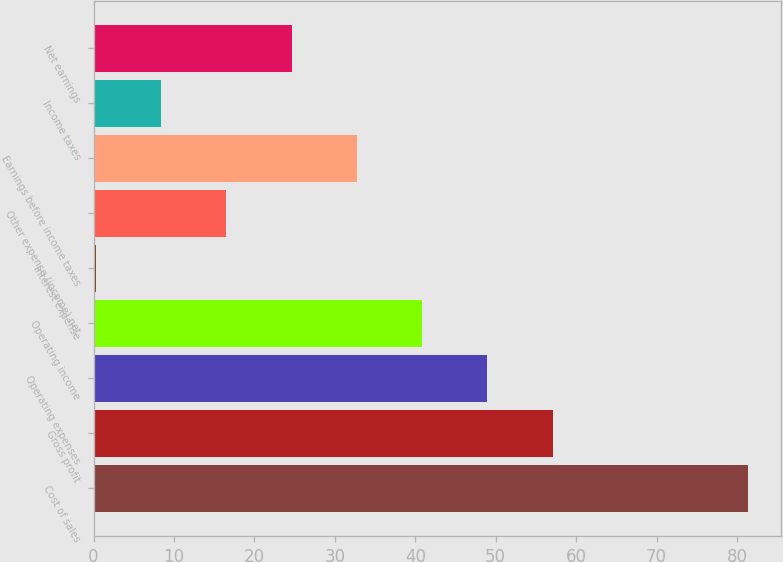Convert chart to OTSL. <chart><loc_0><loc_0><loc_500><loc_500><bar_chart><fcel>Cost of sales<fcel>Gross profit<fcel>Operating expenses<fcel>Operating income<fcel>Interest expense<fcel>Other expense (income) net<fcel>Earnings before income taxes<fcel>Income taxes<fcel>Net earnings<nl><fcel>81.4<fcel>57.07<fcel>48.96<fcel>40.85<fcel>0.3<fcel>16.52<fcel>32.74<fcel>8.41<fcel>24.63<nl></chart> 